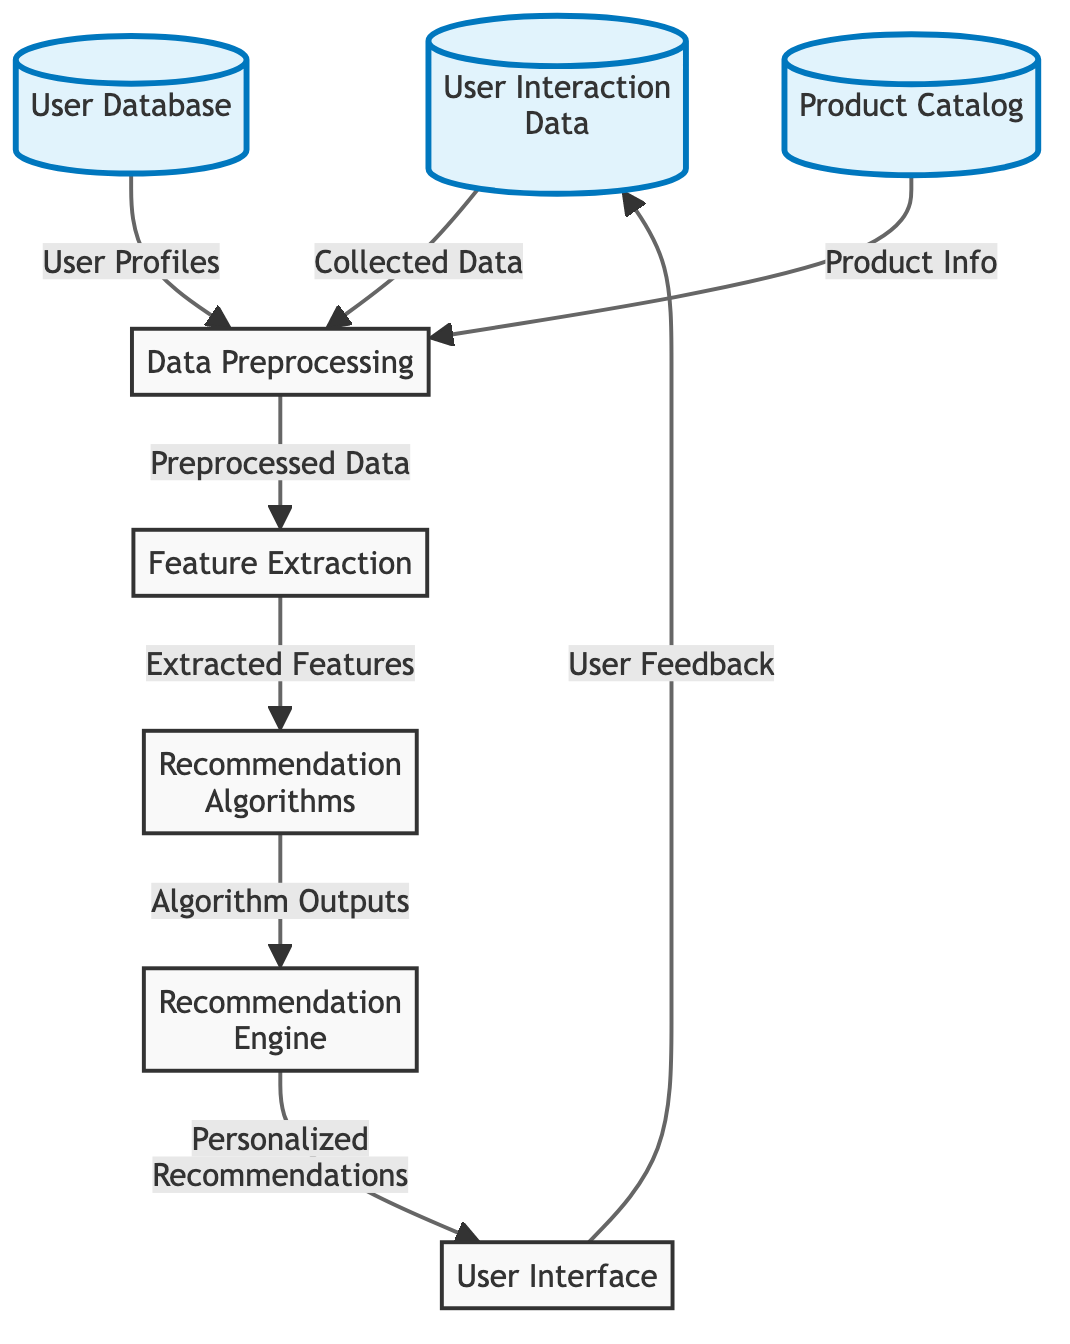What is the first node in the diagram? The first node in the diagram is labeled "User Interaction Data," which collects data generated from users interacting with the e-commerce platform.
Answer: User Interaction Data How many nodes are there in total? By counting each unique element represented in the diagram, we see there are a total of eight nodes connected by arrows showing the data flow.
Answer: Eight Which component provides "User Profiles" to the data preprocessing stage? The component labeled "User Database" supplies the user profiles that are essential for preprocessing user-related data in the recommendation system.
Answer: User Database What type of information is sent from "Product Catalog" to "Data Preprocessing"? The information that is sent from the "Product Catalog" to "Data Preprocessing" consists of relevant product information necessary for tailored recommendations.
Answer: Product Info Where do "Personalized Recommendations" go after being generated by the recommendation engine? After being generated by the recommendation engine, "Personalized Recommendations" are sent to the "User Interface," allowing users to see the suggested products based on their profile and interaction history.
Answer: User Interface What feedback loop is established in this architecture? The architecture establishes a feedback loop where "User Feedback" is collected and sent back to the "User Interaction Data" node, helping to refine and improve future recommendations based on user reactions.
Answer: User Feedback What happens to the information in "Data Preprocessing"? In the "Data Preprocessing" stage, the collected data from the user interaction and user profiles is analyzed and structured into a format suitable for feature extraction, preparing it for more advanced recommendation algorithms.
Answer: Preprocessed Data Which stage utilizes "Extracted Features"? The "Recommendation Algorithms" stage utilizes the extracted features, which are derived from preprocessed data, to generate recommendations tailored to user preferences and interests.
Answer: Recommendation Algorithms What color represents the "Recommendation Engine" node? The "Recommendation Engine" node is represented by the color pink, indicated by the fill color in the diagram.
Answer: Pink 